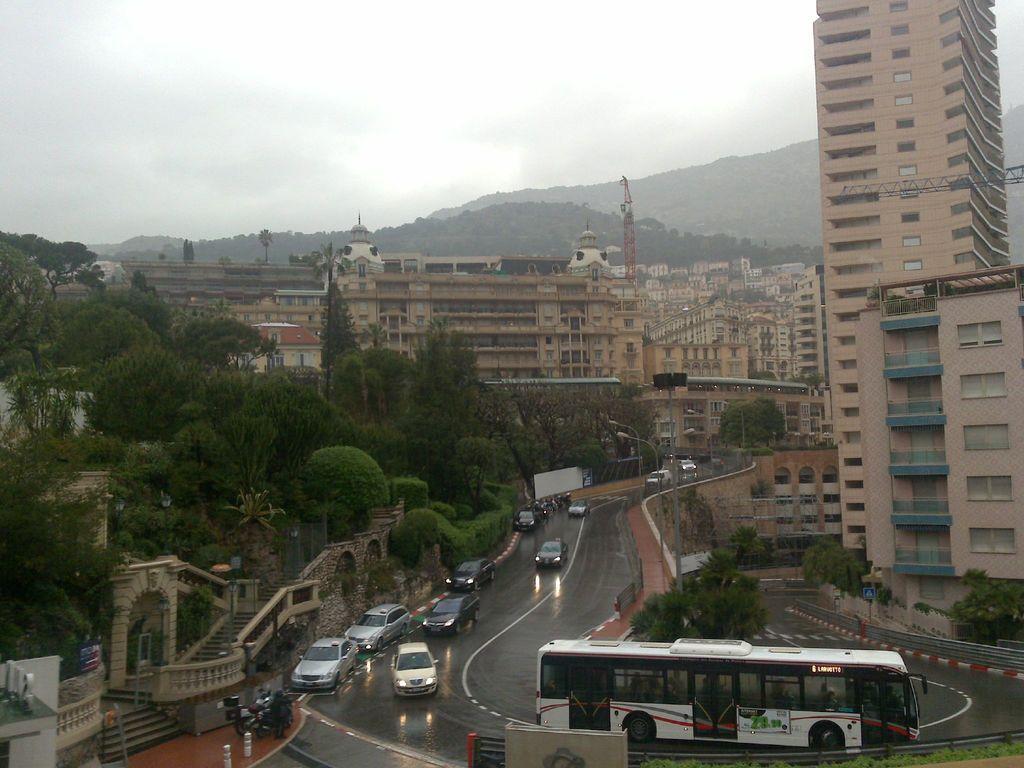How would you summarize this image in a sentence or two? This image is clicked from top view. In this image, we can see many cars and buses on the road. On the left, there are trees. In the background, there buildings and mountains. At the top, there are clouds in the sky. 